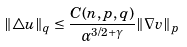Convert formula to latex. <formula><loc_0><loc_0><loc_500><loc_500>\| \triangle u \| _ { q } \leq \frac { C ( n , p , q ) } { \alpha ^ { 3 / 2 + \gamma } } \| \nabla v \| _ { p }</formula> 